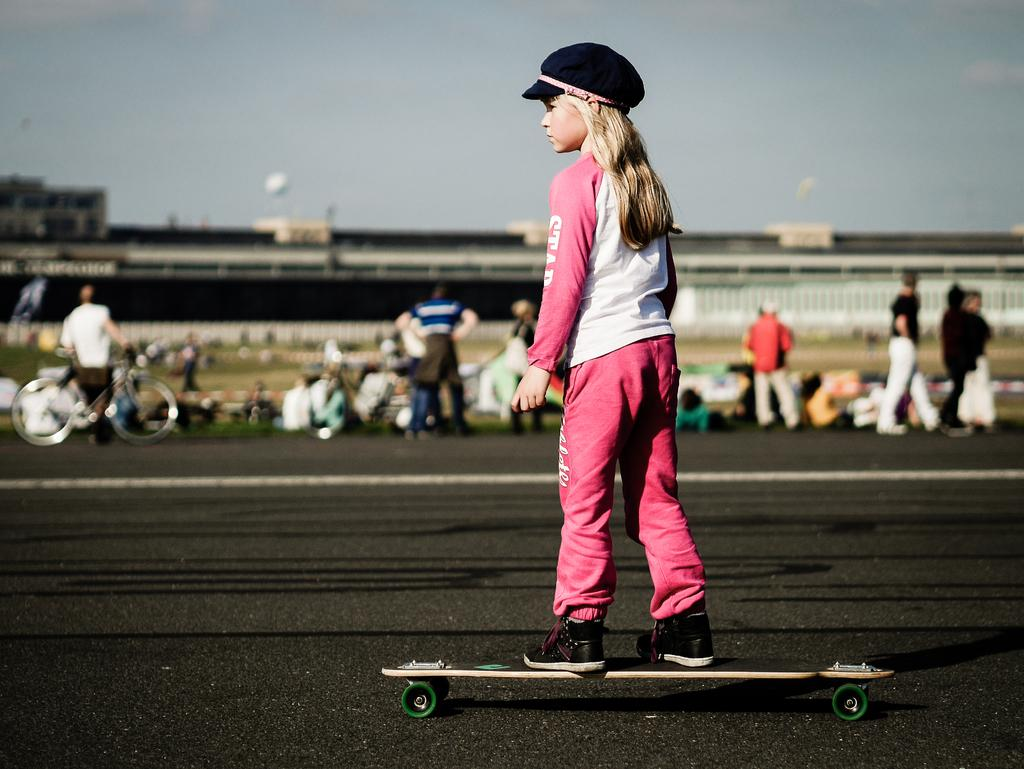Who is the main subject in the image? There is a girl in the image. What is the girl doing in the image? The girl is on a skateboard. Where is the girl located in the image? The girl is in the middle of the image. What can be seen in the background of the image? There are people and the sky visible in the background of the image. What type of appliance is the girl using to perform tricks in the image? There is no appliance present in the image; the girl is riding a skateboard. What rule is the girl breaking by performing tricks on the skateboard in the image? There is no indication in the image that the girl is breaking any rules. 